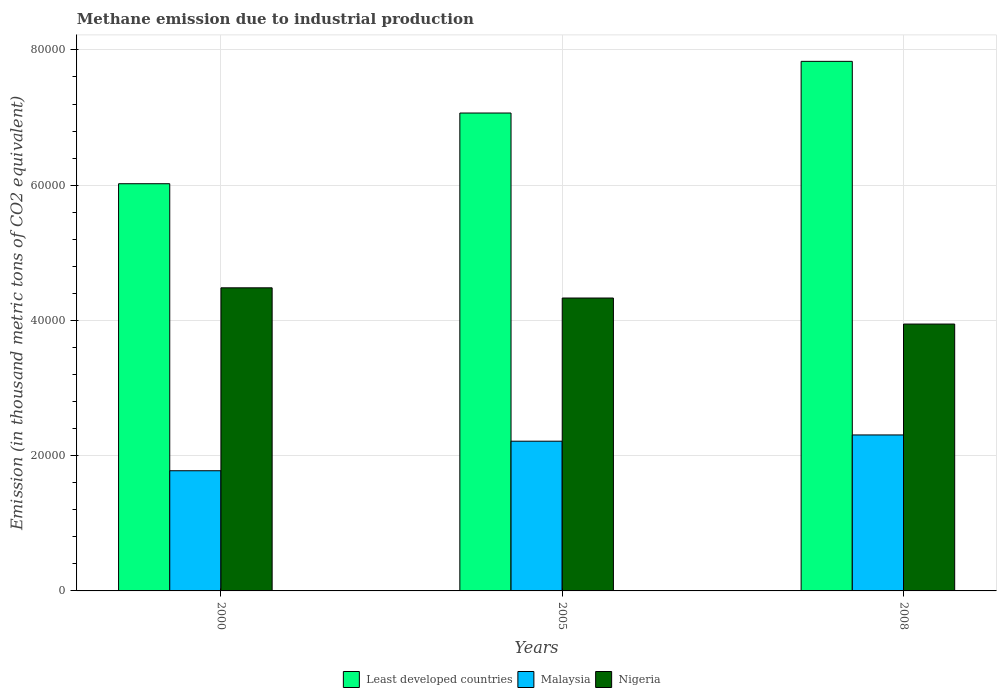How many different coloured bars are there?
Provide a short and direct response. 3. How many groups of bars are there?
Provide a succinct answer. 3. Are the number of bars per tick equal to the number of legend labels?
Provide a short and direct response. Yes. What is the label of the 3rd group of bars from the left?
Provide a short and direct response. 2008. What is the amount of methane emitted in Nigeria in 2000?
Your response must be concise. 4.48e+04. Across all years, what is the maximum amount of methane emitted in Least developed countries?
Provide a short and direct response. 7.83e+04. Across all years, what is the minimum amount of methane emitted in Malaysia?
Ensure brevity in your answer.  1.78e+04. In which year was the amount of methane emitted in Malaysia maximum?
Keep it short and to the point. 2008. What is the total amount of methane emitted in Nigeria in the graph?
Ensure brevity in your answer.  1.28e+05. What is the difference between the amount of methane emitted in Nigeria in 2000 and that in 2008?
Provide a succinct answer. 5359.1. What is the difference between the amount of methane emitted in Malaysia in 2000 and the amount of methane emitted in Least developed countries in 2005?
Offer a very short reply. -5.29e+04. What is the average amount of methane emitted in Least developed countries per year?
Your answer should be very brief. 6.97e+04. In the year 2000, what is the difference between the amount of methane emitted in Malaysia and amount of methane emitted in Least developed countries?
Provide a short and direct response. -4.24e+04. In how many years, is the amount of methane emitted in Malaysia greater than 60000 thousand metric tons?
Your answer should be very brief. 0. What is the ratio of the amount of methane emitted in Least developed countries in 2000 to that in 2008?
Make the answer very short. 0.77. What is the difference between the highest and the second highest amount of methane emitted in Least developed countries?
Keep it short and to the point. 7639.7. What is the difference between the highest and the lowest amount of methane emitted in Least developed countries?
Ensure brevity in your answer.  1.81e+04. Is the sum of the amount of methane emitted in Least developed countries in 2000 and 2008 greater than the maximum amount of methane emitted in Malaysia across all years?
Give a very brief answer. Yes. What does the 3rd bar from the left in 2000 represents?
Your response must be concise. Nigeria. What does the 3rd bar from the right in 2008 represents?
Make the answer very short. Least developed countries. How many years are there in the graph?
Provide a succinct answer. 3. Are the values on the major ticks of Y-axis written in scientific E-notation?
Your answer should be compact. No. Does the graph contain any zero values?
Provide a short and direct response. No. What is the title of the graph?
Your answer should be very brief. Methane emission due to industrial production. Does "China" appear as one of the legend labels in the graph?
Ensure brevity in your answer.  No. What is the label or title of the Y-axis?
Provide a short and direct response. Emission (in thousand metric tons of CO2 equivalent). What is the Emission (in thousand metric tons of CO2 equivalent) in Least developed countries in 2000?
Offer a very short reply. 6.02e+04. What is the Emission (in thousand metric tons of CO2 equivalent) of Malaysia in 2000?
Your answer should be compact. 1.78e+04. What is the Emission (in thousand metric tons of CO2 equivalent) in Nigeria in 2000?
Provide a short and direct response. 4.48e+04. What is the Emission (in thousand metric tons of CO2 equivalent) in Least developed countries in 2005?
Provide a succinct answer. 7.07e+04. What is the Emission (in thousand metric tons of CO2 equivalent) in Malaysia in 2005?
Offer a terse response. 2.21e+04. What is the Emission (in thousand metric tons of CO2 equivalent) in Nigeria in 2005?
Your answer should be compact. 4.33e+04. What is the Emission (in thousand metric tons of CO2 equivalent) in Least developed countries in 2008?
Give a very brief answer. 7.83e+04. What is the Emission (in thousand metric tons of CO2 equivalent) in Malaysia in 2008?
Offer a terse response. 2.31e+04. What is the Emission (in thousand metric tons of CO2 equivalent) of Nigeria in 2008?
Ensure brevity in your answer.  3.95e+04. Across all years, what is the maximum Emission (in thousand metric tons of CO2 equivalent) of Least developed countries?
Make the answer very short. 7.83e+04. Across all years, what is the maximum Emission (in thousand metric tons of CO2 equivalent) of Malaysia?
Make the answer very short. 2.31e+04. Across all years, what is the maximum Emission (in thousand metric tons of CO2 equivalent) in Nigeria?
Make the answer very short. 4.48e+04. Across all years, what is the minimum Emission (in thousand metric tons of CO2 equivalent) of Least developed countries?
Your response must be concise. 6.02e+04. Across all years, what is the minimum Emission (in thousand metric tons of CO2 equivalent) of Malaysia?
Offer a very short reply. 1.78e+04. Across all years, what is the minimum Emission (in thousand metric tons of CO2 equivalent) in Nigeria?
Make the answer very short. 3.95e+04. What is the total Emission (in thousand metric tons of CO2 equivalent) of Least developed countries in the graph?
Offer a very short reply. 2.09e+05. What is the total Emission (in thousand metric tons of CO2 equivalent) in Malaysia in the graph?
Your answer should be very brief. 6.30e+04. What is the total Emission (in thousand metric tons of CO2 equivalent) of Nigeria in the graph?
Provide a succinct answer. 1.28e+05. What is the difference between the Emission (in thousand metric tons of CO2 equivalent) in Least developed countries in 2000 and that in 2005?
Your answer should be compact. -1.05e+04. What is the difference between the Emission (in thousand metric tons of CO2 equivalent) in Malaysia in 2000 and that in 2005?
Your response must be concise. -4367.4. What is the difference between the Emission (in thousand metric tons of CO2 equivalent) of Nigeria in 2000 and that in 2005?
Your answer should be very brief. 1509.9. What is the difference between the Emission (in thousand metric tons of CO2 equivalent) of Least developed countries in 2000 and that in 2008?
Offer a very short reply. -1.81e+04. What is the difference between the Emission (in thousand metric tons of CO2 equivalent) in Malaysia in 2000 and that in 2008?
Provide a succinct answer. -5293.2. What is the difference between the Emission (in thousand metric tons of CO2 equivalent) in Nigeria in 2000 and that in 2008?
Your response must be concise. 5359.1. What is the difference between the Emission (in thousand metric tons of CO2 equivalent) in Least developed countries in 2005 and that in 2008?
Provide a short and direct response. -7639.7. What is the difference between the Emission (in thousand metric tons of CO2 equivalent) of Malaysia in 2005 and that in 2008?
Your response must be concise. -925.8. What is the difference between the Emission (in thousand metric tons of CO2 equivalent) in Nigeria in 2005 and that in 2008?
Make the answer very short. 3849.2. What is the difference between the Emission (in thousand metric tons of CO2 equivalent) in Least developed countries in 2000 and the Emission (in thousand metric tons of CO2 equivalent) in Malaysia in 2005?
Your answer should be compact. 3.81e+04. What is the difference between the Emission (in thousand metric tons of CO2 equivalent) of Least developed countries in 2000 and the Emission (in thousand metric tons of CO2 equivalent) of Nigeria in 2005?
Offer a terse response. 1.69e+04. What is the difference between the Emission (in thousand metric tons of CO2 equivalent) in Malaysia in 2000 and the Emission (in thousand metric tons of CO2 equivalent) in Nigeria in 2005?
Your response must be concise. -2.55e+04. What is the difference between the Emission (in thousand metric tons of CO2 equivalent) in Least developed countries in 2000 and the Emission (in thousand metric tons of CO2 equivalent) in Malaysia in 2008?
Provide a succinct answer. 3.71e+04. What is the difference between the Emission (in thousand metric tons of CO2 equivalent) in Least developed countries in 2000 and the Emission (in thousand metric tons of CO2 equivalent) in Nigeria in 2008?
Offer a very short reply. 2.08e+04. What is the difference between the Emission (in thousand metric tons of CO2 equivalent) of Malaysia in 2000 and the Emission (in thousand metric tons of CO2 equivalent) of Nigeria in 2008?
Ensure brevity in your answer.  -2.17e+04. What is the difference between the Emission (in thousand metric tons of CO2 equivalent) of Least developed countries in 2005 and the Emission (in thousand metric tons of CO2 equivalent) of Malaysia in 2008?
Ensure brevity in your answer.  4.76e+04. What is the difference between the Emission (in thousand metric tons of CO2 equivalent) in Least developed countries in 2005 and the Emission (in thousand metric tons of CO2 equivalent) in Nigeria in 2008?
Provide a short and direct response. 3.12e+04. What is the difference between the Emission (in thousand metric tons of CO2 equivalent) in Malaysia in 2005 and the Emission (in thousand metric tons of CO2 equivalent) in Nigeria in 2008?
Give a very brief answer. -1.73e+04. What is the average Emission (in thousand metric tons of CO2 equivalent) in Least developed countries per year?
Your answer should be compact. 6.97e+04. What is the average Emission (in thousand metric tons of CO2 equivalent) in Malaysia per year?
Your answer should be compact. 2.10e+04. What is the average Emission (in thousand metric tons of CO2 equivalent) of Nigeria per year?
Provide a succinct answer. 4.25e+04. In the year 2000, what is the difference between the Emission (in thousand metric tons of CO2 equivalent) of Least developed countries and Emission (in thousand metric tons of CO2 equivalent) of Malaysia?
Your answer should be very brief. 4.24e+04. In the year 2000, what is the difference between the Emission (in thousand metric tons of CO2 equivalent) of Least developed countries and Emission (in thousand metric tons of CO2 equivalent) of Nigeria?
Offer a very short reply. 1.54e+04. In the year 2000, what is the difference between the Emission (in thousand metric tons of CO2 equivalent) of Malaysia and Emission (in thousand metric tons of CO2 equivalent) of Nigeria?
Offer a very short reply. -2.70e+04. In the year 2005, what is the difference between the Emission (in thousand metric tons of CO2 equivalent) of Least developed countries and Emission (in thousand metric tons of CO2 equivalent) of Malaysia?
Offer a very short reply. 4.85e+04. In the year 2005, what is the difference between the Emission (in thousand metric tons of CO2 equivalent) of Least developed countries and Emission (in thousand metric tons of CO2 equivalent) of Nigeria?
Offer a terse response. 2.74e+04. In the year 2005, what is the difference between the Emission (in thousand metric tons of CO2 equivalent) of Malaysia and Emission (in thousand metric tons of CO2 equivalent) of Nigeria?
Provide a succinct answer. -2.12e+04. In the year 2008, what is the difference between the Emission (in thousand metric tons of CO2 equivalent) of Least developed countries and Emission (in thousand metric tons of CO2 equivalent) of Malaysia?
Keep it short and to the point. 5.52e+04. In the year 2008, what is the difference between the Emission (in thousand metric tons of CO2 equivalent) in Least developed countries and Emission (in thousand metric tons of CO2 equivalent) in Nigeria?
Your answer should be very brief. 3.88e+04. In the year 2008, what is the difference between the Emission (in thousand metric tons of CO2 equivalent) in Malaysia and Emission (in thousand metric tons of CO2 equivalent) in Nigeria?
Your answer should be compact. -1.64e+04. What is the ratio of the Emission (in thousand metric tons of CO2 equivalent) in Least developed countries in 2000 to that in 2005?
Offer a very short reply. 0.85. What is the ratio of the Emission (in thousand metric tons of CO2 equivalent) in Malaysia in 2000 to that in 2005?
Make the answer very short. 0.8. What is the ratio of the Emission (in thousand metric tons of CO2 equivalent) in Nigeria in 2000 to that in 2005?
Ensure brevity in your answer.  1.03. What is the ratio of the Emission (in thousand metric tons of CO2 equivalent) of Least developed countries in 2000 to that in 2008?
Provide a succinct answer. 0.77. What is the ratio of the Emission (in thousand metric tons of CO2 equivalent) in Malaysia in 2000 to that in 2008?
Ensure brevity in your answer.  0.77. What is the ratio of the Emission (in thousand metric tons of CO2 equivalent) in Nigeria in 2000 to that in 2008?
Offer a terse response. 1.14. What is the ratio of the Emission (in thousand metric tons of CO2 equivalent) of Least developed countries in 2005 to that in 2008?
Give a very brief answer. 0.9. What is the ratio of the Emission (in thousand metric tons of CO2 equivalent) in Malaysia in 2005 to that in 2008?
Make the answer very short. 0.96. What is the ratio of the Emission (in thousand metric tons of CO2 equivalent) in Nigeria in 2005 to that in 2008?
Offer a terse response. 1.1. What is the difference between the highest and the second highest Emission (in thousand metric tons of CO2 equivalent) in Least developed countries?
Offer a very short reply. 7639.7. What is the difference between the highest and the second highest Emission (in thousand metric tons of CO2 equivalent) of Malaysia?
Your response must be concise. 925.8. What is the difference between the highest and the second highest Emission (in thousand metric tons of CO2 equivalent) in Nigeria?
Your answer should be compact. 1509.9. What is the difference between the highest and the lowest Emission (in thousand metric tons of CO2 equivalent) in Least developed countries?
Make the answer very short. 1.81e+04. What is the difference between the highest and the lowest Emission (in thousand metric tons of CO2 equivalent) of Malaysia?
Make the answer very short. 5293.2. What is the difference between the highest and the lowest Emission (in thousand metric tons of CO2 equivalent) of Nigeria?
Ensure brevity in your answer.  5359.1. 